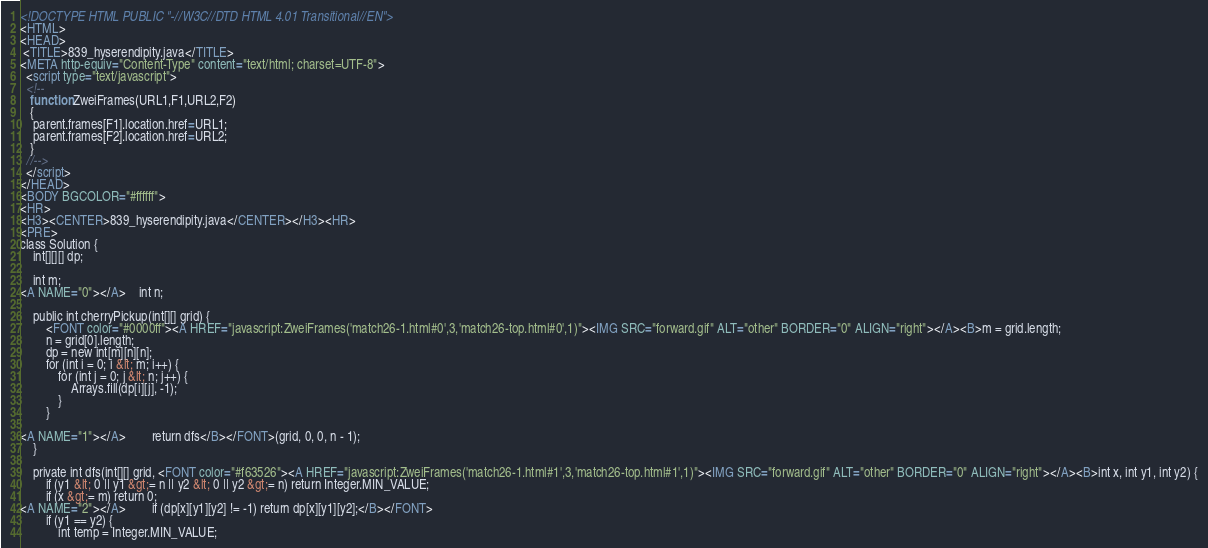Convert code to text. <code><loc_0><loc_0><loc_500><loc_500><_HTML_><!DOCTYPE HTML PUBLIC "-//W3C//DTD HTML 4.01 Transitional//EN">
<HTML>
<HEAD>
 <TITLE>839_hyserendipity.java</TITLE>
<META http-equiv="Content-Type" content="text/html; charset=UTF-8">
  <script type="text/javascript">
  <!--
   function ZweiFrames(URL1,F1,URL2,F2)
   {
    parent.frames[F1].location.href=URL1;
    parent.frames[F2].location.href=URL2;
   }
  //-->
  </script>
</HEAD>
<BODY BGCOLOR="#ffffff">
<HR>
<H3><CENTER>839_hyserendipity.java</CENTER></H3><HR>
<PRE>
class Solution {
    int[][][] dp;
    
    int m;
<A NAME="0"></A>    int n;
    
    public int cherryPickup(int[][] grid) {
        <FONT color="#0000ff"><A HREF="javascript:ZweiFrames('match26-1.html#0',3,'match26-top.html#0',1)"><IMG SRC="forward.gif" ALT="other" BORDER="0" ALIGN="right"></A><B>m = grid.length;
        n = grid[0].length;
        dp = new int[m][n][n];
        for (int i = 0; i &lt; m; i++) {
            for (int j = 0; j &lt; n; j++) {
                Arrays.fill(dp[i][j], -1);
            }
        }
        
<A NAME="1"></A>        return dfs</B></FONT>(grid, 0, 0, n - 1);
    }
    
    private int dfs(int[][] grid, <FONT color="#f63526"><A HREF="javascript:ZweiFrames('match26-1.html#1',3,'match26-top.html#1',1)"><IMG SRC="forward.gif" ALT="other" BORDER="0" ALIGN="right"></A><B>int x, int y1, int y2) {
        if (y1 &lt; 0 || y1 &gt;= n || y2 &lt; 0 || y2 &gt;= n) return Integer.MIN_VALUE;
        if (x &gt;= m) return 0;
<A NAME="2"></A>        if (dp[x][y1][y2] != -1) return dp[x][y1][y2];</B></FONT>
        if (y1 == y2) {
            int temp = Integer.MIN_VALUE;</code> 